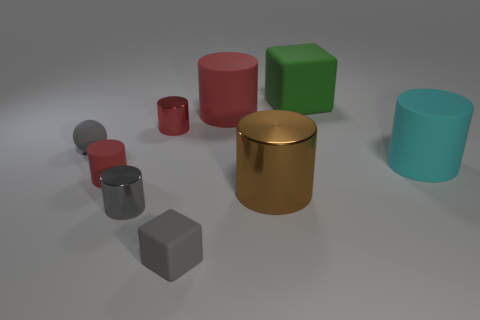Subtract all purple cubes. How many red cylinders are left? 3 Subtract all large cyan cylinders. How many cylinders are left? 5 Subtract all brown cylinders. How many cylinders are left? 5 Add 1 small green cubes. How many objects exist? 10 Subtract all blue cylinders. Subtract all red cubes. How many cylinders are left? 6 Subtract all cylinders. How many objects are left? 3 Add 7 red things. How many red things exist? 10 Subtract 0 purple cubes. How many objects are left? 9 Subtract all purple metallic things. Subtract all cylinders. How many objects are left? 3 Add 8 small metal objects. How many small metal objects are left? 10 